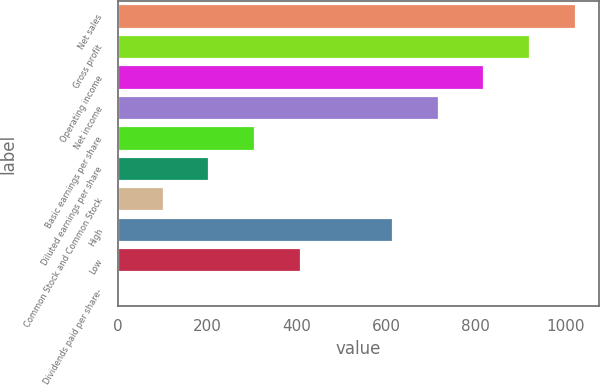Convert chart to OTSL. <chart><loc_0><loc_0><loc_500><loc_500><bar_chart><fcel>Net sales<fcel>Gross profit<fcel>Operating income<fcel>Net income<fcel>Basic earnings per share<fcel>Diluted earnings per share<fcel>Common Stock and Common Stock<fcel>High<fcel>Low<fcel>Dividends paid per share-<nl><fcel>1024.1<fcel>921.7<fcel>819.33<fcel>716.96<fcel>307.48<fcel>205.11<fcel>102.74<fcel>614.59<fcel>409.85<fcel>0.37<nl></chart> 